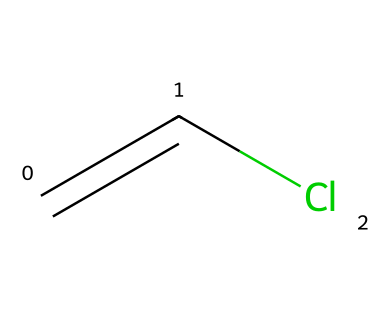What is the name of this chemical? The chemical is represented by the SMILES notation C=CCl, where "C" denotes carbon atoms, "C=C" indicates a double bond between two carbon atoms, and "Cl" signifies a chlorine atom. Thus, it is identified as vinyl chloride monomer.
Answer: vinyl chloride monomer How many carbon atoms are in this molecule? Analyzing the SMILES string C=CCl reveals that there are two "C" characters, indicating two carbon atoms present in the molecule.
Answer: 2 How many total atoms are in the molecule? The SMILES notation C=CCl represents two carbon atoms (C), one chlorine atom (Cl), and no hydrogen atoms explicitly shown. However, each carbon generally bonds with enough hydrogen atoms to satisfy its four bonding capacity. Here, each carbon has one hydrogen as well, totaling four atoms: two carbons and two hydrogens in addition to one chlorine.
Answer: 5 What type of bond is present between the carbon atoms? The notation "C=C" in the SMILES indicates a double bond between the two carbon atoms, which is characterized by two shared pairs of electrons.
Answer: double bond Is this compound polar or nonpolar? The presence of a chlorine atom, which is more electronegative than carbon, creates a dipole moment due to the difference in electronegativity. This causes the molecule to have a polar character, as the unequal sharing of electrons leads to a partial negative charge near the chlorine and partial positive charges near the carbon atoms.
Answer: polar What is the state of this chemical at room temperature? Vinyl chloride monomer is part of the group of chemicals known as volatile liquids and typically exists as a gas at room temperature due to its low boiling point of around 13 degrees Celsius. Therefore, under standard conditions, it would be in the gaseous state.
Answer: gas 